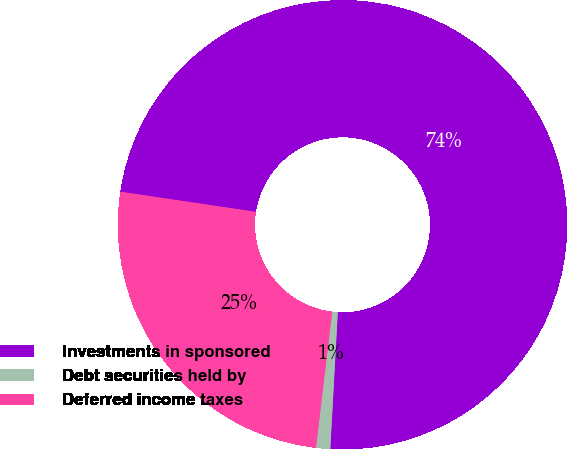Convert chart to OTSL. <chart><loc_0><loc_0><loc_500><loc_500><pie_chart><fcel>Investments in sponsored<fcel>Debt securities held by<fcel>Deferred income taxes<nl><fcel>73.52%<fcel>1.02%<fcel>25.46%<nl></chart> 